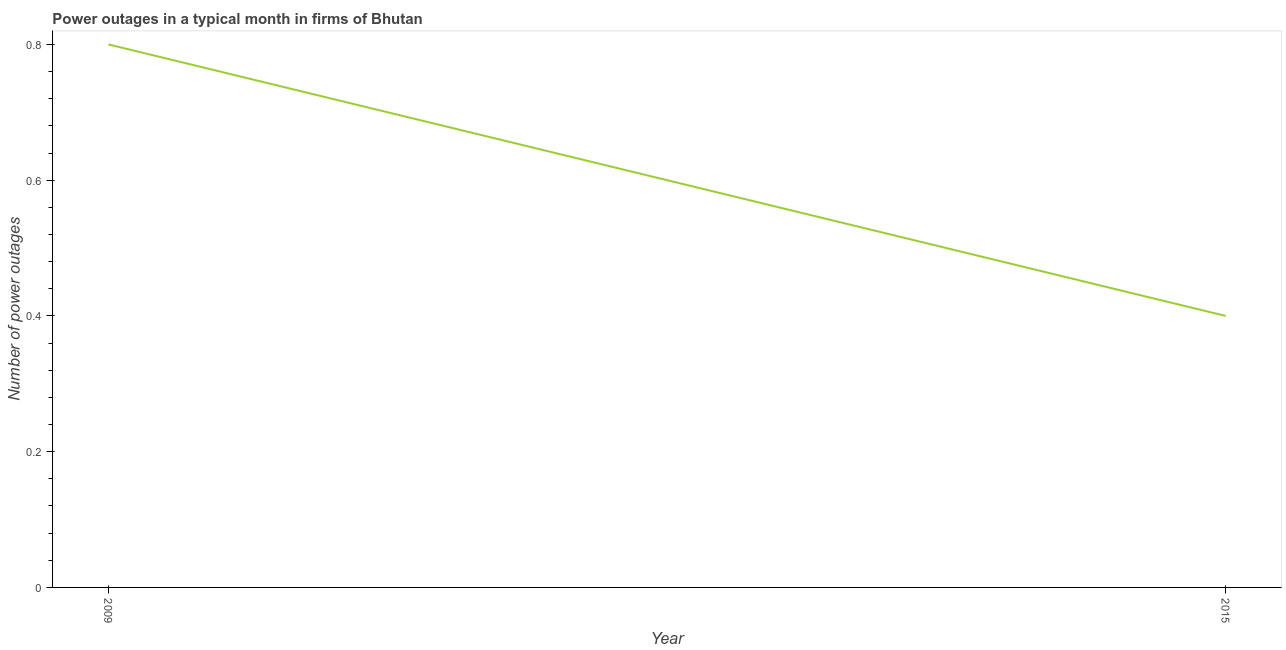Across all years, what is the maximum number of power outages?
Offer a very short reply. 0.8. In which year was the number of power outages minimum?
Your answer should be compact. 2015. What is the sum of the number of power outages?
Offer a very short reply. 1.2. What is the difference between the number of power outages in 2009 and 2015?
Keep it short and to the point. 0.4. What is the average number of power outages per year?
Provide a short and direct response. 0.6. What is the median number of power outages?
Offer a terse response. 0.6. In how many years, is the number of power outages greater than 0.6000000000000001 ?
Provide a succinct answer. 1. Do a majority of the years between 2009 and 2015 (inclusive) have number of power outages greater than 0.2 ?
Make the answer very short. Yes. What is the ratio of the number of power outages in 2009 to that in 2015?
Your response must be concise. 2. In how many years, is the number of power outages greater than the average number of power outages taken over all years?
Offer a very short reply. 1. Does the number of power outages monotonically increase over the years?
Your answer should be compact. No. What is the difference between two consecutive major ticks on the Y-axis?
Keep it short and to the point. 0.2. What is the title of the graph?
Make the answer very short. Power outages in a typical month in firms of Bhutan. What is the label or title of the X-axis?
Offer a very short reply. Year. What is the label or title of the Y-axis?
Make the answer very short. Number of power outages. What is the Number of power outages of 2009?
Ensure brevity in your answer.  0.8. What is the difference between the Number of power outages in 2009 and 2015?
Your answer should be very brief. 0.4. What is the ratio of the Number of power outages in 2009 to that in 2015?
Your response must be concise. 2. 